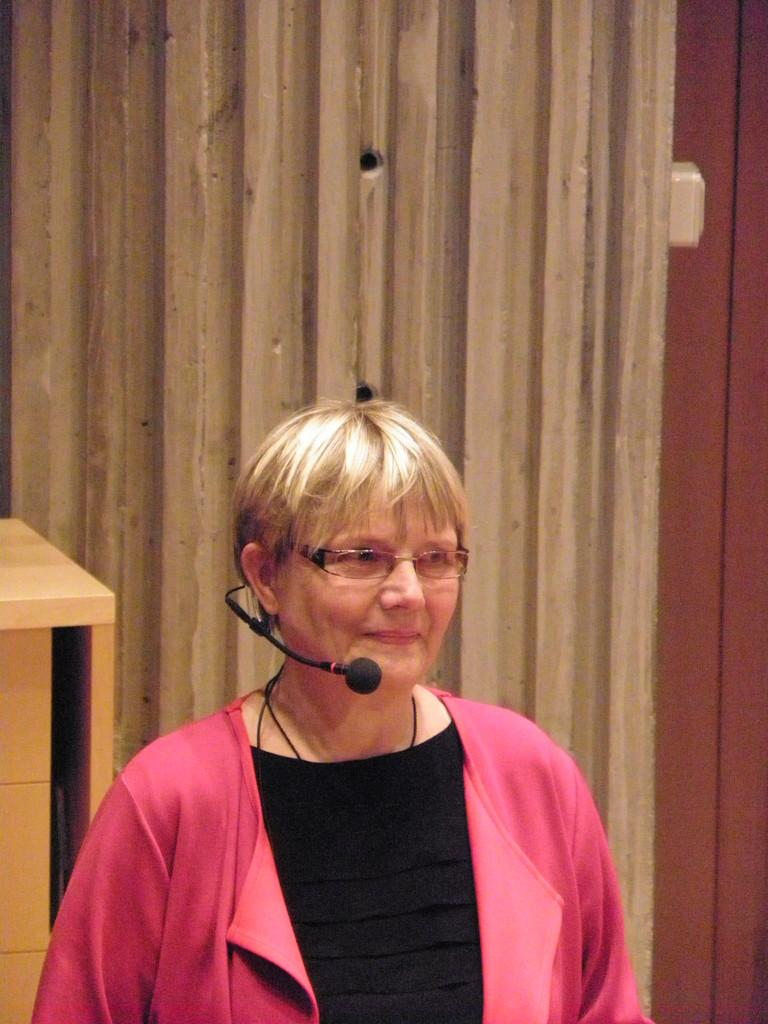Who is the main subject in the image? There is an old woman in the image. What is the appearance of the woman's hair? The woman has blond hair. What is the woman wearing in the image? The woman is wearing a peach jacket. What is the woman holding in the image? The woman is holding a mic. Where is the woman positioned in the image? The woman is standing in the front of the image. What can be seen in the background of the image? There is a wall in the background of the image. What is located on the left side of the image? There is a table on the left side of the image. What type of suit is the woman wearing in the image? The woman is not wearing a suit in the image; she is wearing a peach jacket. Can you see any cables connected to the mic the woman is holding? There is no mention of cables in the image, so it cannot be determined if any are connected to the mic. 